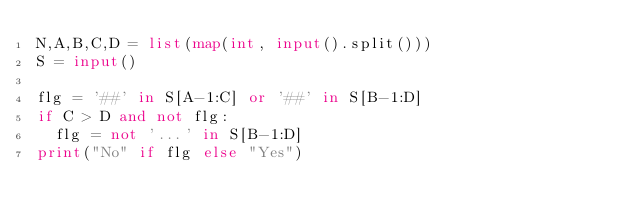Convert code to text. <code><loc_0><loc_0><loc_500><loc_500><_Python_>N,A,B,C,D = list(map(int, input().split()))
S = input()

flg = '##' in S[A-1:C] or '##' in S[B-1:D]
if C > D and not flg:
  flg = not '...' in S[B-1:D]
print("No" if flg else "Yes")</code> 